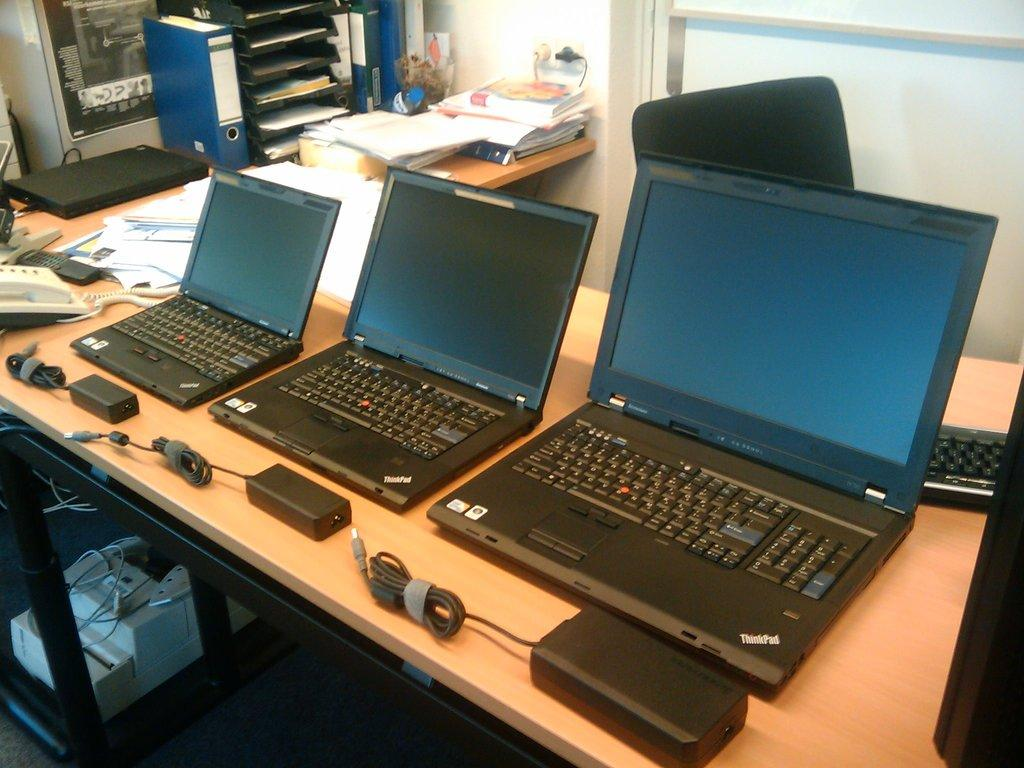<image>
Create a compact narrative representing the image presented. Three different size laptops with Thinkpad in the lower right corner. 